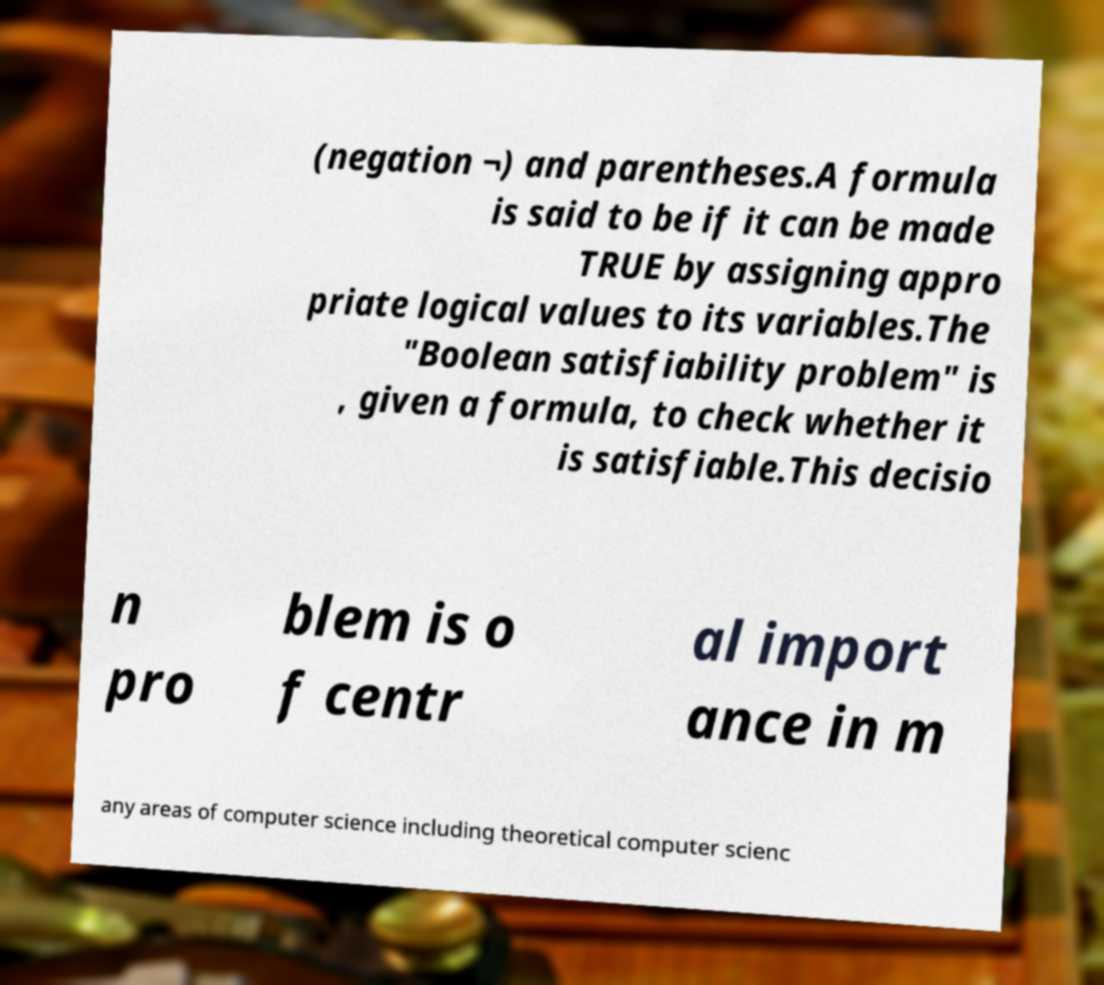Can you accurately transcribe the text from the provided image for me? (negation ¬) and parentheses.A formula is said to be if it can be made TRUE by assigning appro priate logical values to its variables.The "Boolean satisfiability problem" is , given a formula, to check whether it is satisfiable.This decisio n pro blem is o f centr al import ance in m any areas of computer science including theoretical computer scienc 